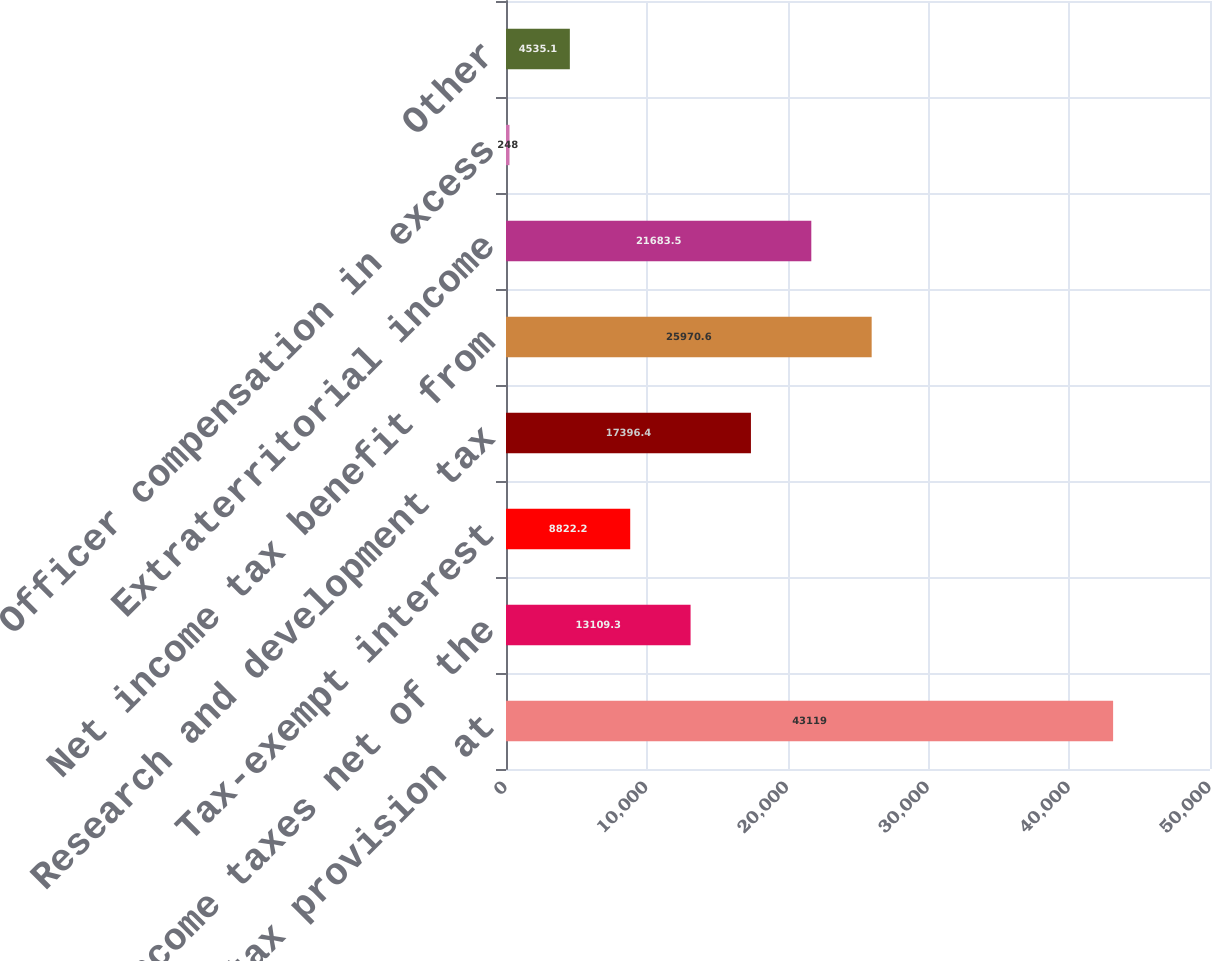Convert chart to OTSL. <chart><loc_0><loc_0><loc_500><loc_500><bar_chart><fcel>Income tax provision at<fcel>State income taxes net of the<fcel>Tax-exempt interest<fcel>Research and development tax<fcel>Net income tax benefit from<fcel>Extraterritorial income<fcel>Officer compensation in excess<fcel>Other<nl><fcel>43119<fcel>13109.3<fcel>8822.2<fcel>17396.4<fcel>25970.6<fcel>21683.5<fcel>248<fcel>4535.1<nl></chart> 